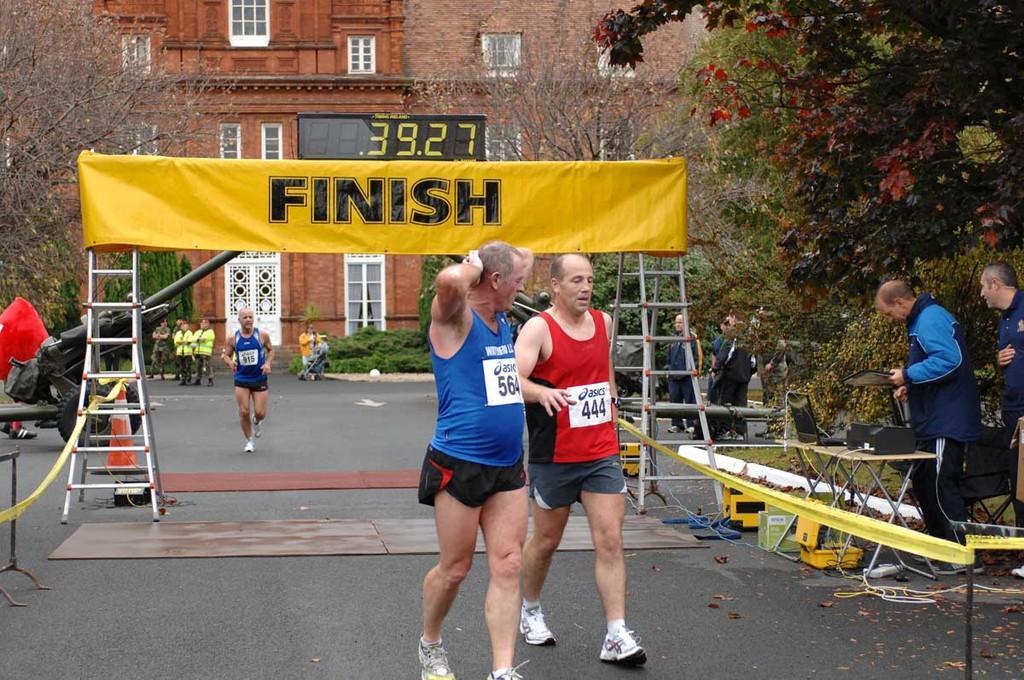How would you summarize this image in a sentence or two? In this image we can see, there are two people walking in the foreground, in the middle there is the finish line board, on the right there are some tree. 